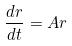<formula> <loc_0><loc_0><loc_500><loc_500>\frac { d r } { d t } = A r</formula> 